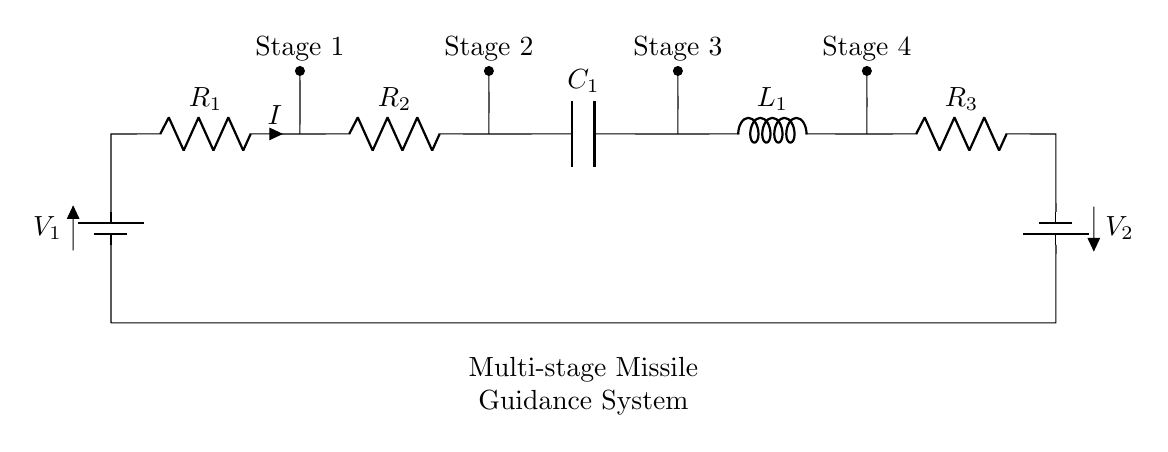What are the resistors in this circuit? The components labeled as resistors are R1, R2, and R3. They indicate that there are three resistive elements in the series circuit.
Answer: R1, R2, R3 What is the role of C1 in this circuit? C1 is a capacitor, which typically stores electrical energy and smooths voltage fluctuations within the circuit, essential for stability in guidance systems.
Answer: Capacitor How many stages does the multi-stage missile guidance system have? The diagram indicates four stages, as labeled above the components in the series circuit.
Answer: Four What is the total voltage supplied to the circuit? The total voltage is the sum of V1 and V2, as they are connected in series providing a cumulative potential difference.
Answer: V1 + V2 What is the connection type of this circuit? The circuit is a series connection, evidenced by the configuration where all components are connected end-to-end, meaning the same current flows through each element.
Answer: Series What happens to the current as it passes through R1, R2, and R3? The current remains the same through each resistor since in a series circuit, the current does not change and is equal across all components.
Answer: Same current What component is found after Stage 4 in the circuit? After Stage 4, the next component is R3, which indicates the sequence of resistive elements after the stages of the missile system.
Answer: R3 